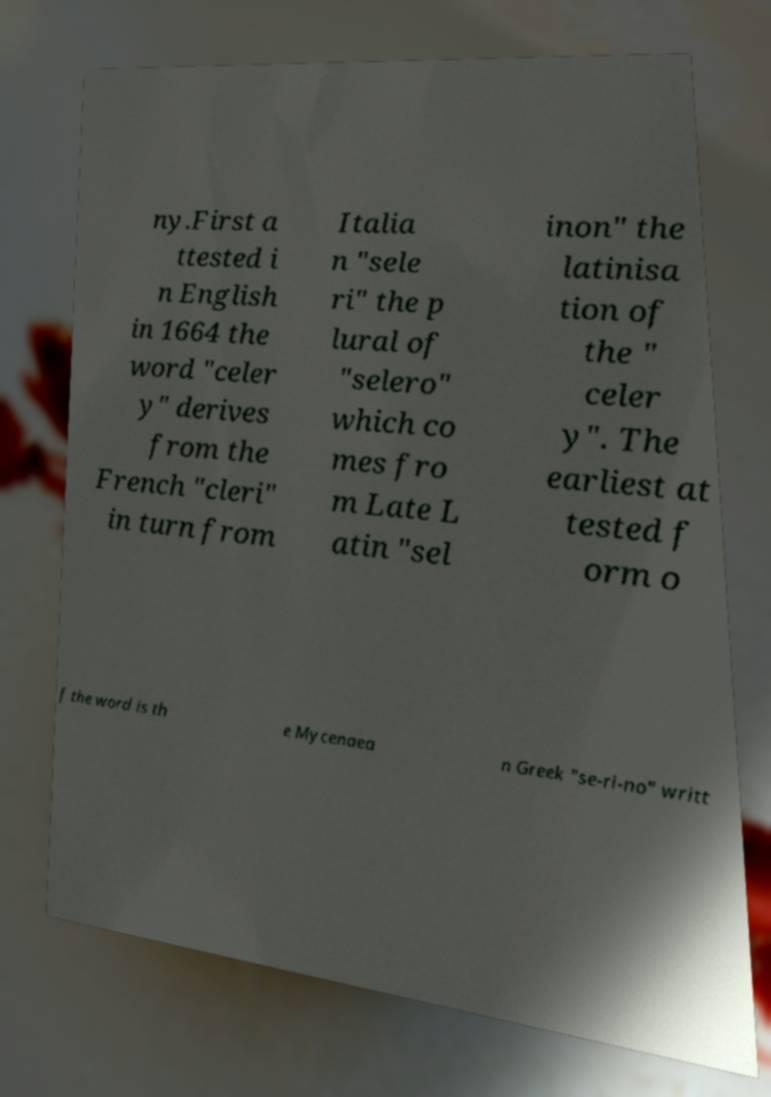Could you extract and type out the text from this image? ny.First a ttested i n English in 1664 the word "celer y" derives from the French "cleri" in turn from Italia n "sele ri" the p lural of "selero" which co mes fro m Late L atin "sel inon" the latinisa tion of the " celer y". The earliest at tested f orm o f the word is th e Mycenaea n Greek "se-ri-no" writt 